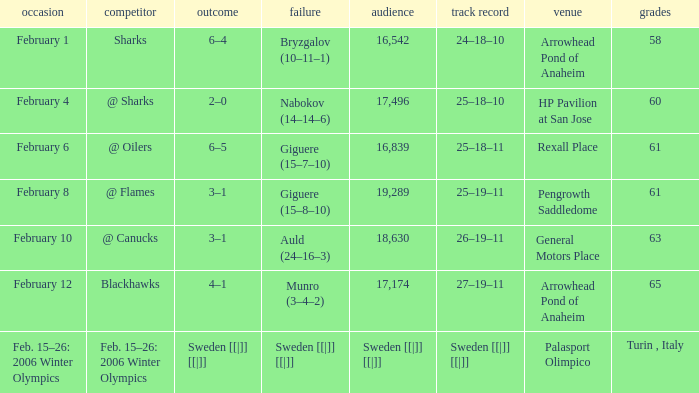What is the record at Arrowhead Pond of Anaheim, when the loss was Bryzgalov (10–11–1)? 24–18–10. 